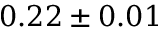Convert formula to latex. <formula><loc_0><loc_0><loc_500><loc_500>0 . 2 2 \pm 0 . 0 1</formula> 